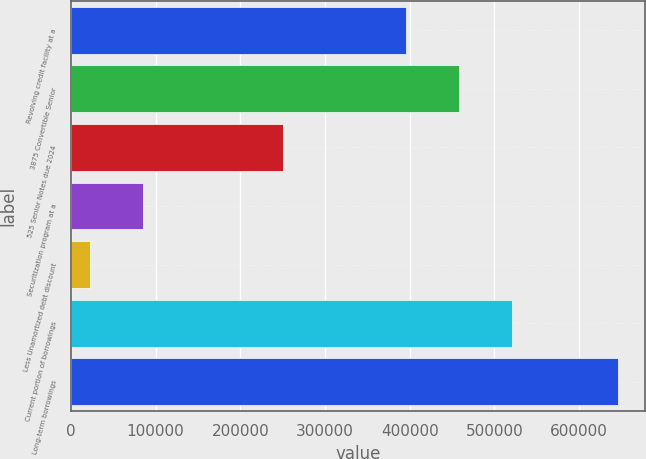Convert chart. <chart><loc_0><loc_0><loc_500><loc_500><bar_chart><fcel>Revolving credit facility at a<fcel>3875 Convertible Senior<fcel>525 Senior Notes due 2024<fcel>Securitization program at a<fcel>Less Unamortized debt discount<fcel>Current portion of borrowings<fcel>Long-term borrowings<nl><fcel>396000<fcel>458300<fcel>250000<fcel>85299.1<fcel>22999<fcel>520600<fcel>646000<nl></chart> 